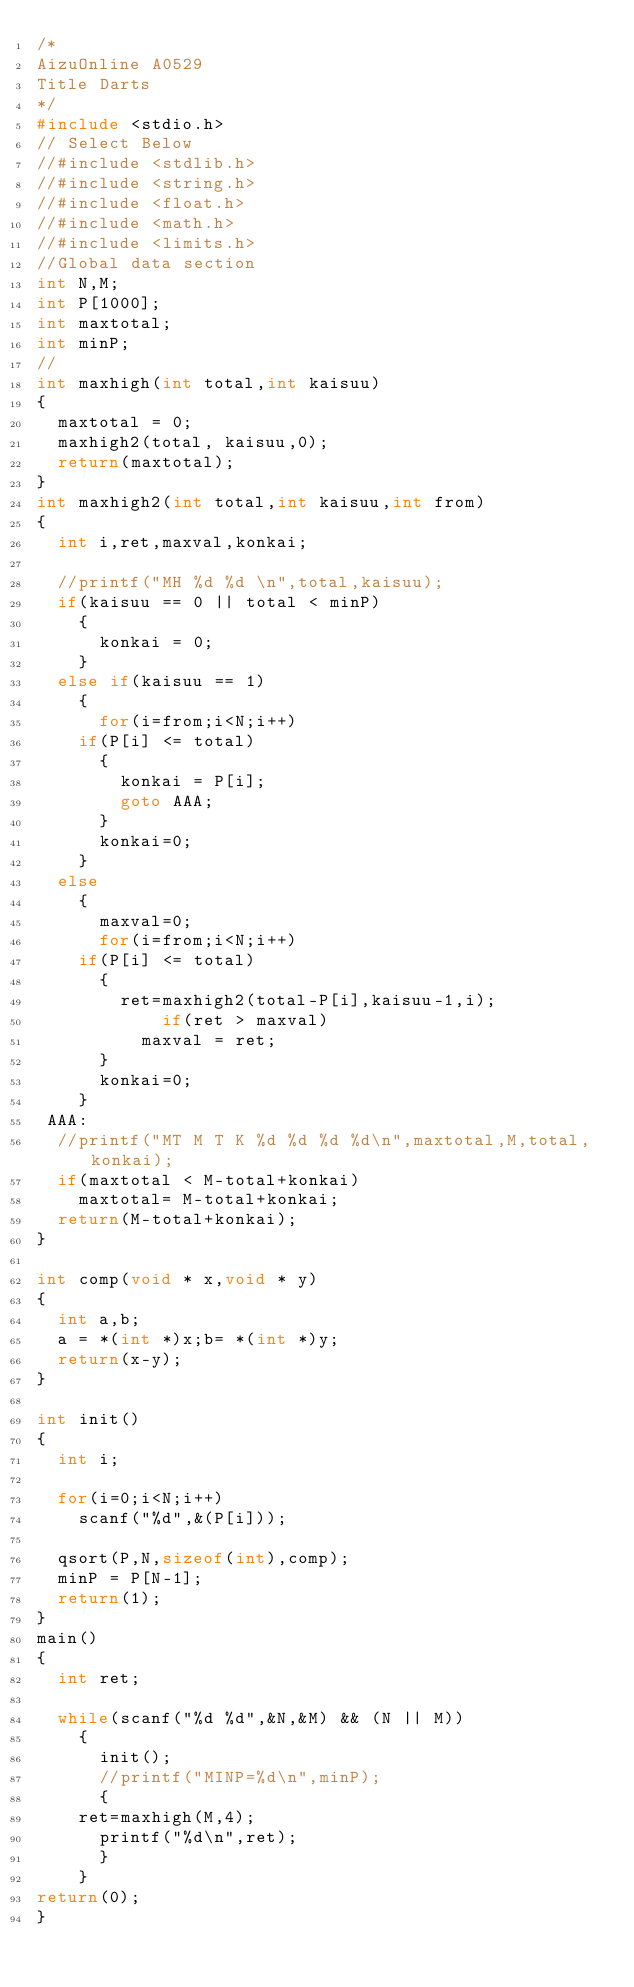Convert code to text. <code><loc_0><loc_0><loc_500><loc_500><_C_>/*
AizuOnline A0529
Title Darts
*/
#include <stdio.h>
// Select Below
//#include <stdlib.h>
//#include <string.h>
//#include <float.h>
//#include <math.h>
//#include <limits.h>
//Global data section
int N,M;
int P[1000];
int maxtotal;
int minP;
//
int maxhigh(int total,int kaisuu)
{
  maxtotal = 0;
  maxhigh2(total, kaisuu,0);
  return(maxtotal);
}
int maxhigh2(int total,int kaisuu,int from)
{
  int i,ret,maxval,konkai;

  //printf("MH %d %d \n",total,kaisuu);
  if(kaisuu == 0 || total < minP)
    {
      konkai = 0;
    }
  else if(kaisuu == 1)
    {
      for(i=from;i<N;i++)
	if(P[i] <= total)
	  {
	    konkai = P[i];
	    goto AAA;
	  }
      konkai=0;
    }
  else
    {
      maxval=0;
      for(i=from;i<N;i++)
	if(P[i] <= total)
	  {
	    ret=maxhigh2(total-P[i],kaisuu-1,i);
            if(ret > maxval)
	      maxval = ret;
	  }
      konkai=0;
    }
 AAA:
  //printf("MT M T K %d %d %d %d\n",maxtotal,M,total,konkai);
  if(maxtotal < M-total+konkai)
    maxtotal= M-total+konkai;
  return(M-total+konkai);
}

int comp(void * x,void * y)
{
  int a,b;
  a = *(int *)x;b= *(int *)y;
  return(x-y);
}

int init()
{
  int i;

  for(i=0;i<N;i++)
    scanf("%d",&(P[i]));

  qsort(P,N,sizeof(int),comp);
  minP = P[N-1];
  return(1);
}
main()
{
  int ret;

  while(scanf("%d %d",&N,&M) && (N || M))
    {
      init();
      //printf("MINP=%d\n",minP);
      {
	ret=maxhigh(M,4);
      printf("%d\n",ret);
      }
    }
return(0);
}</code> 